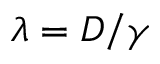Convert formula to latex. <formula><loc_0><loc_0><loc_500><loc_500>\lambda = D / \gamma</formula> 